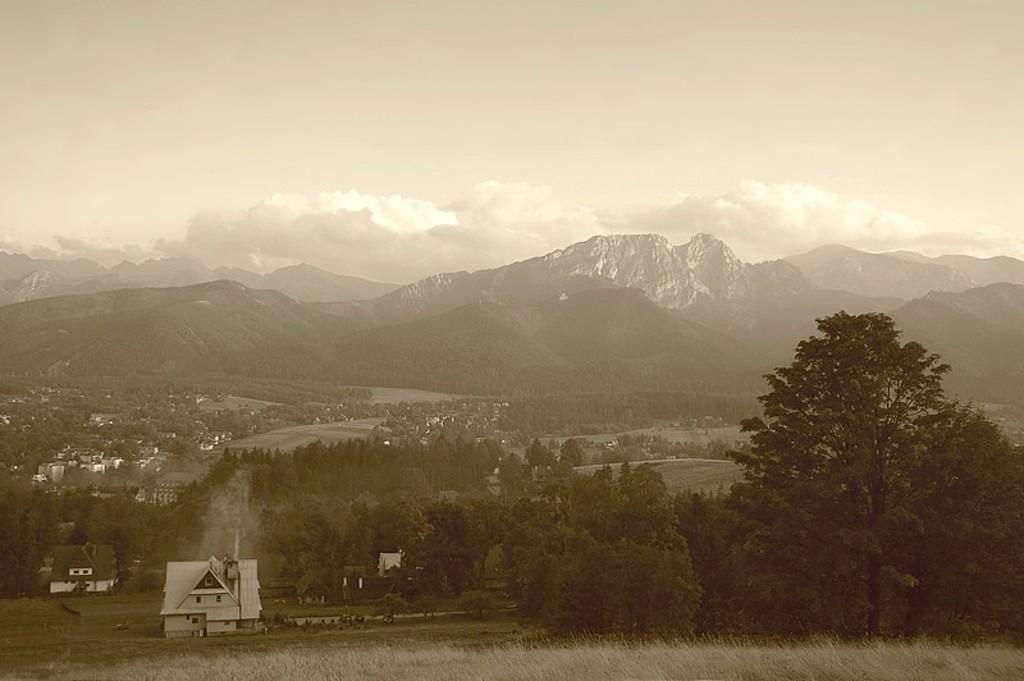Please provide a concise description of this image. In this image we can see houses, grass, trees, and mountain. In the background there is sky with clouds. 